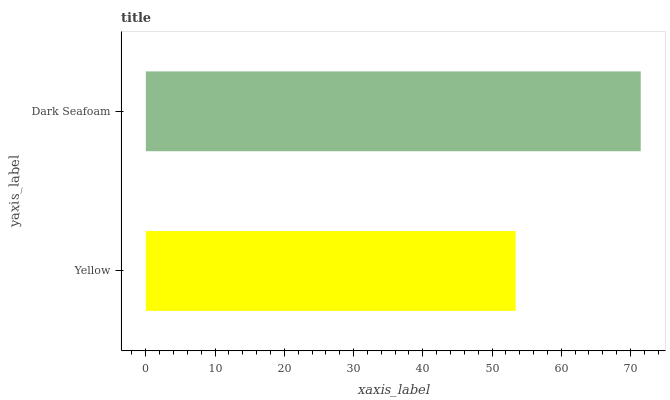Is Yellow the minimum?
Answer yes or no. Yes. Is Dark Seafoam the maximum?
Answer yes or no. Yes. Is Dark Seafoam the minimum?
Answer yes or no. No. Is Dark Seafoam greater than Yellow?
Answer yes or no. Yes. Is Yellow less than Dark Seafoam?
Answer yes or no. Yes. Is Yellow greater than Dark Seafoam?
Answer yes or no. No. Is Dark Seafoam less than Yellow?
Answer yes or no. No. Is Dark Seafoam the high median?
Answer yes or no. Yes. Is Yellow the low median?
Answer yes or no. Yes. Is Yellow the high median?
Answer yes or no. No. Is Dark Seafoam the low median?
Answer yes or no. No. 